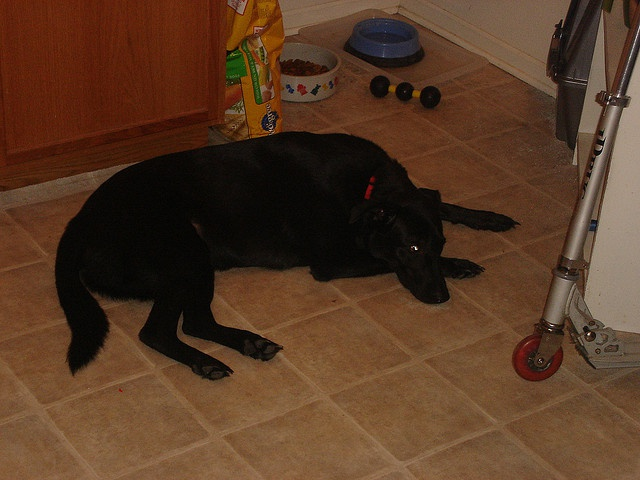Describe the objects in this image and their specific colors. I can see dog in maroon, black, and brown tones, bowl in maroon, black, and gray tones, and bowl in maroon and black tones in this image. 